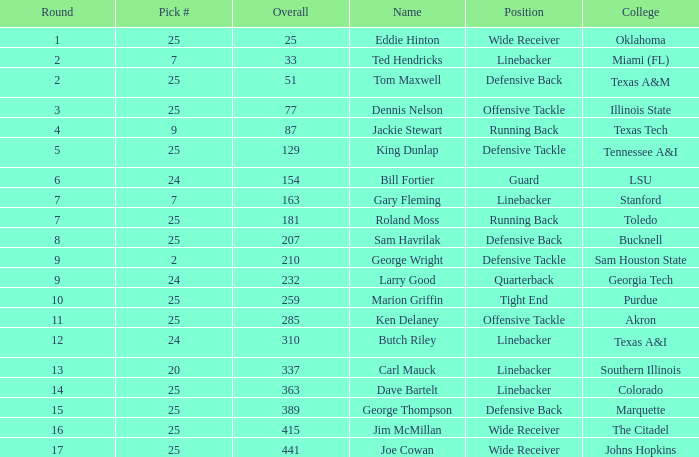Round smaller than 7, and an Overall of 129 is what college? Tennessee A&I. 